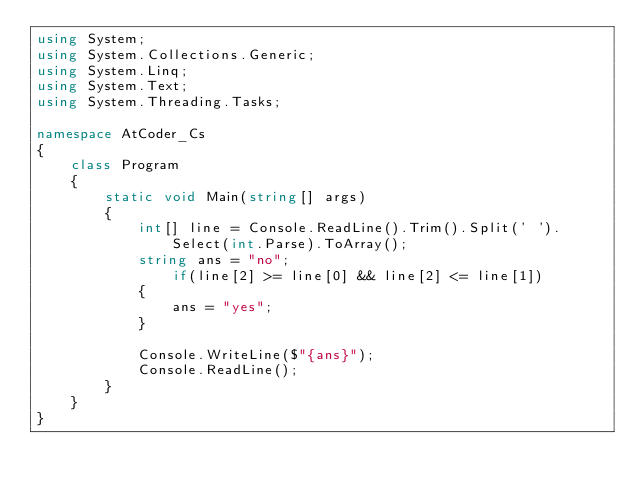<code> <loc_0><loc_0><loc_500><loc_500><_C#_>using System;
using System.Collections.Generic;
using System.Linq;
using System.Text;
using System.Threading.Tasks;

namespace AtCoder_Cs
{
    class Program
    {
        static void Main(string[] args)
        {
            int[] line = Console.ReadLine().Trim().Split(' ').Select(int.Parse).ToArray();
            string ans = "no";
                if(line[2] >= line[0] && line[2] <= line[1])
            {
                ans = "yes";
            }

            Console.WriteLine($"{ans}");
            Console.ReadLine();
        }
    }
}
</code> 